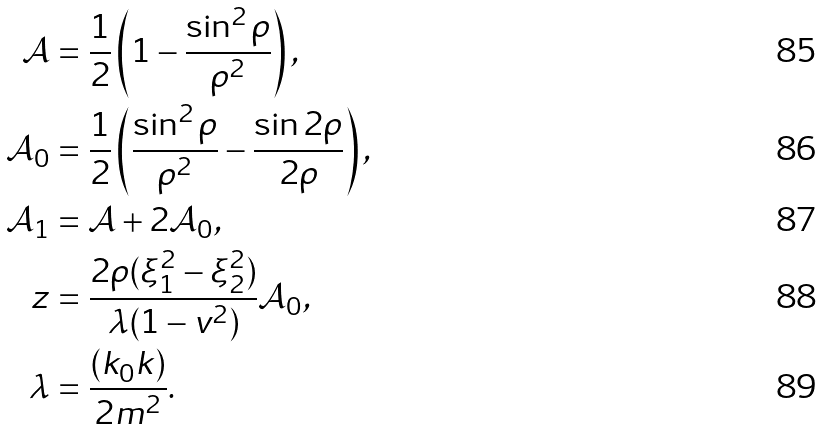Convert formula to latex. <formula><loc_0><loc_0><loc_500><loc_500>\mathcal { A } & = \frac { 1 } { 2 } \left ( 1 - \frac { \sin ^ { 2 } \rho } { \rho ^ { 2 } } \right ) , \\ \mathcal { A } _ { 0 } & = \frac { 1 } { 2 } \left ( \frac { \sin ^ { 2 } \rho } { \rho ^ { 2 } } - \frac { \sin 2 \rho } { 2 \rho } \right ) , \\ \mathcal { A } _ { 1 } & = \mathcal { A } + 2 \mathcal { A } _ { 0 } , \\ z & = \frac { 2 \rho ( \xi _ { 1 } ^ { 2 } - \xi _ { 2 } ^ { 2 } ) } { \lambda ( 1 - v ^ { 2 } ) } \mathcal { A } _ { 0 } , \\ \lambda & = \frac { ( k _ { 0 } k ) } { 2 m ^ { 2 } } .</formula> 